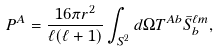Convert formula to latex. <formula><loc_0><loc_0><loc_500><loc_500>P ^ { A } = \frac { 1 6 \pi r ^ { 2 } } { \ell ( \ell + 1 ) } \int _ { S ^ { 2 } } d \Omega T ^ { A b } \bar { S } _ { b } ^ { \ell m } ,</formula> 